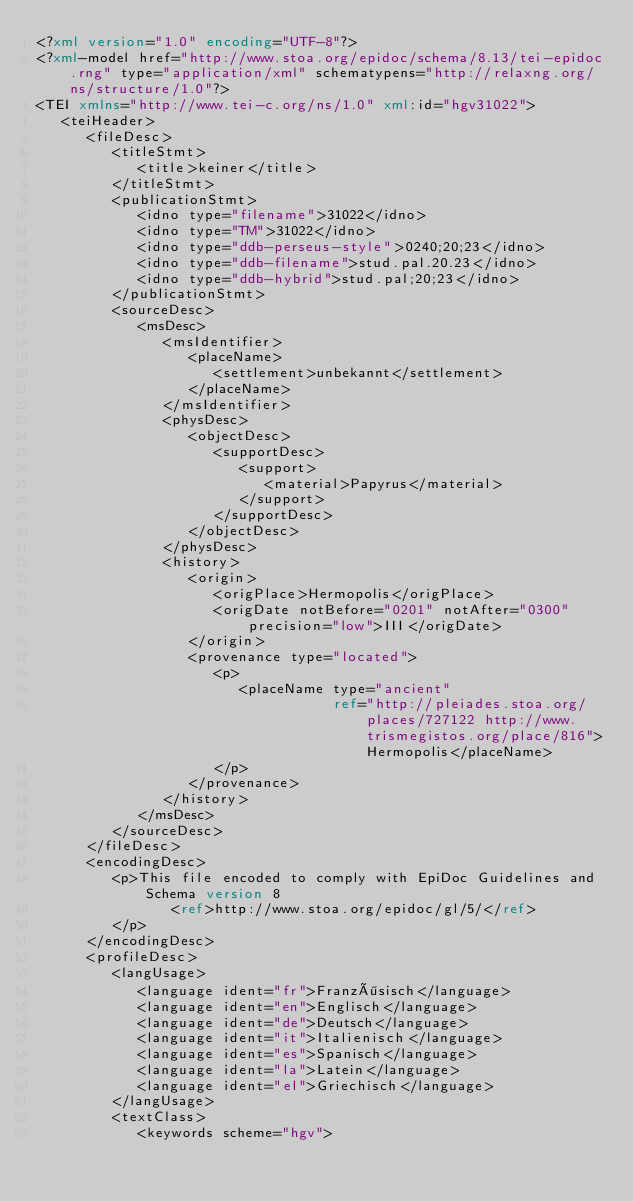Convert code to text. <code><loc_0><loc_0><loc_500><loc_500><_XML_><?xml version="1.0" encoding="UTF-8"?>
<?xml-model href="http://www.stoa.org/epidoc/schema/8.13/tei-epidoc.rng" type="application/xml" schematypens="http://relaxng.org/ns/structure/1.0"?>
<TEI xmlns="http://www.tei-c.org/ns/1.0" xml:id="hgv31022">
   <teiHeader>
      <fileDesc>
         <titleStmt>
            <title>keiner</title>
         </titleStmt>
         <publicationStmt>
            <idno type="filename">31022</idno>
            <idno type="TM">31022</idno>
            <idno type="ddb-perseus-style">0240;20;23</idno>
            <idno type="ddb-filename">stud.pal.20.23</idno>
            <idno type="ddb-hybrid">stud.pal;20;23</idno>
         </publicationStmt>
         <sourceDesc>
            <msDesc>
               <msIdentifier>
                  <placeName>
                     <settlement>unbekannt</settlement>
                  </placeName>
               </msIdentifier>
               <physDesc>
                  <objectDesc>
                     <supportDesc>
                        <support>
                           <material>Papyrus</material>
                        </support>
                     </supportDesc>
                  </objectDesc>
               </physDesc>
               <history>
                  <origin>
                     <origPlace>Hermopolis</origPlace>
                     <origDate notBefore="0201" notAfter="0300" precision="low">III</origDate>
                  </origin>
                  <provenance type="located">
                     <p>
                        <placeName type="ancient"
                                   ref="http://pleiades.stoa.org/places/727122 http://www.trismegistos.org/place/816">Hermopolis</placeName>
                     </p>
                  </provenance>
               </history>
            </msDesc>
         </sourceDesc>
      </fileDesc>
      <encodingDesc>
         <p>This file encoded to comply with EpiDoc Guidelines and Schema version 8
                <ref>http://www.stoa.org/epidoc/gl/5/</ref>
         </p>
      </encodingDesc>
      <profileDesc>
         <langUsage>
            <language ident="fr">Französisch</language>
            <language ident="en">Englisch</language>
            <language ident="de">Deutsch</language>
            <language ident="it">Italienisch</language>
            <language ident="es">Spanisch</language>
            <language ident="la">Latein</language>
            <language ident="el">Griechisch</language>
         </langUsage>
         <textClass>
            <keywords scheme="hgv"></code> 